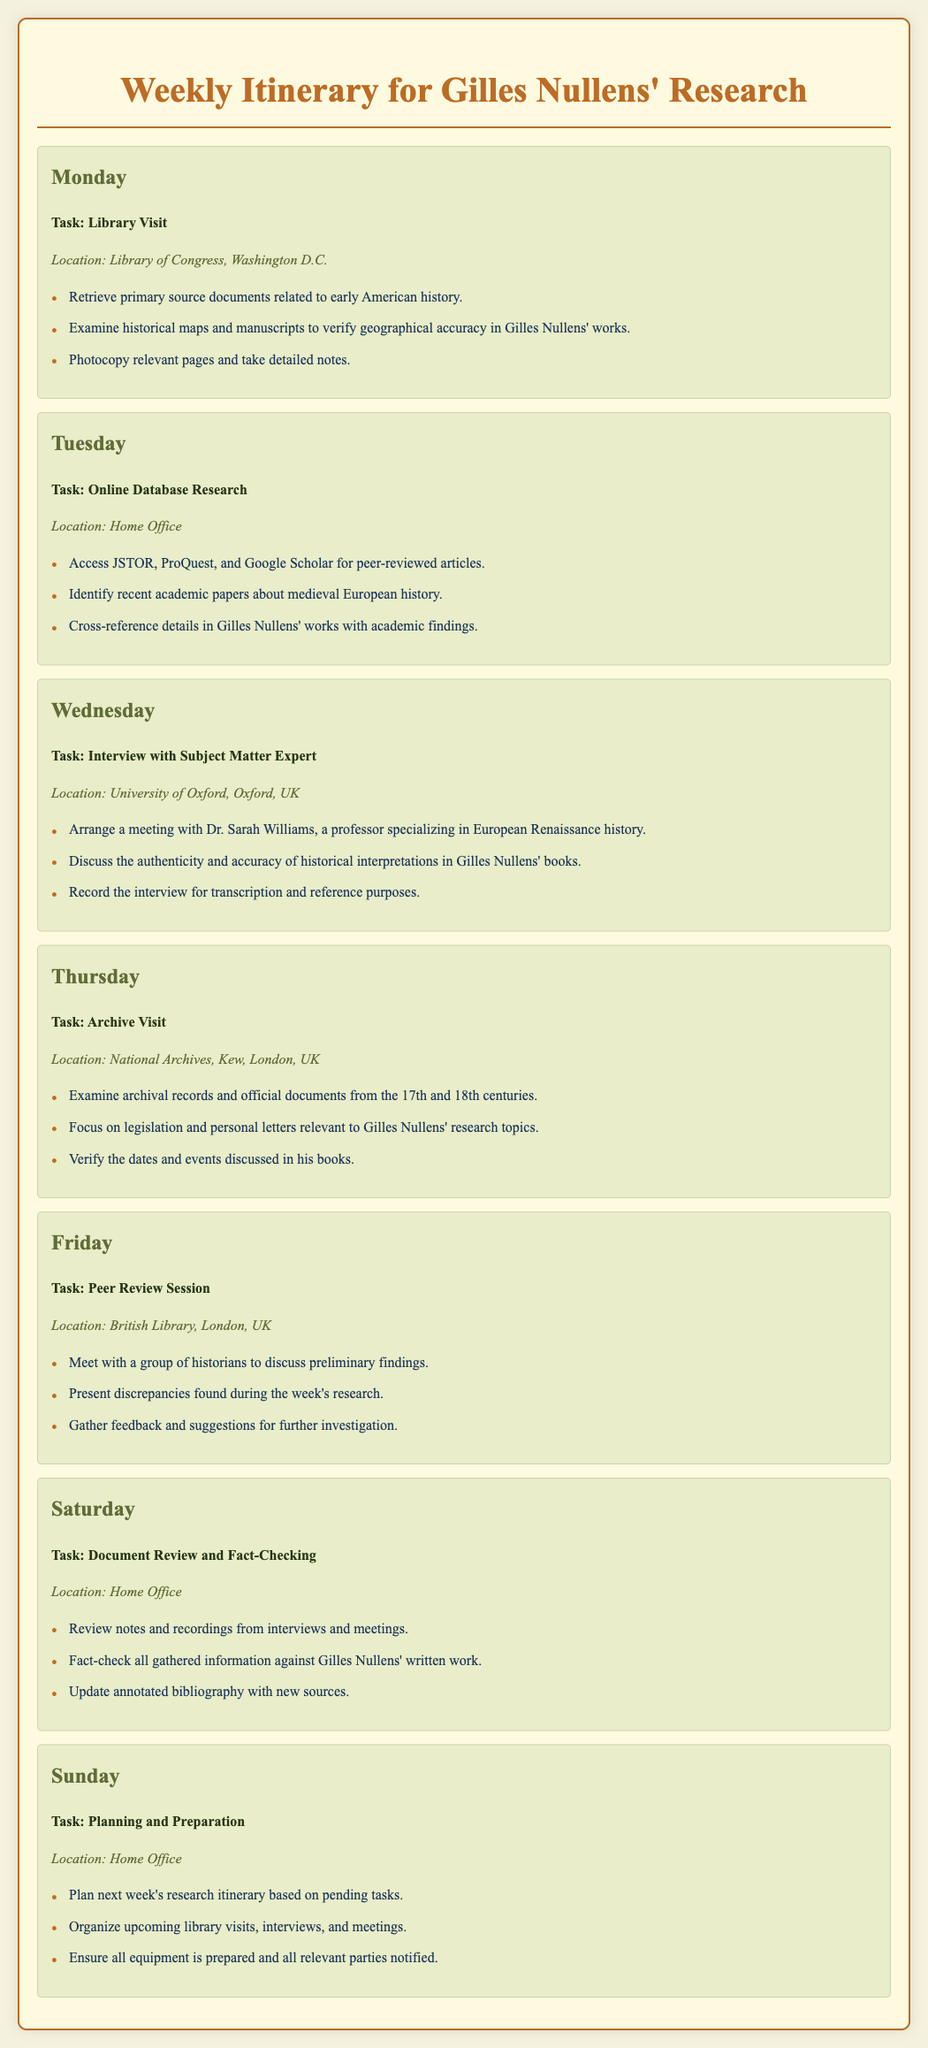What is the task for Monday? The task for Monday involves a library visit to retrieve primary source documents and examine historical maps.
Answer: Library Visit Where is the location for the interview on Wednesday? The document states that the interview with the subject matter expert is taking place at the University of Oxford, Oxford, UK.
Answer: University of Oxford, Oxford, UK Who is the subject matter expert being interviewed? The document provides the name of the expert to be interviewed, who is Dr. Sarah Williams.
Answer: Dr. Sarah Williams What is one task planned for Saturday? The document lists several tasks for Saturday, one of which is to review notes and recordings from interviews and meetings.
Answer: Review notes and recordings What type of session is scheduled for Friday? The itinerary specifies that a peer review session is to be held on Friday.
Answer: Peer Review Session What is a specific activity on Tuesday? On Tuesday, accessing online database research for peer-reviewed articles is mentioned as an activity.
Answer: Access JSTOR, ProQuest, and Google Scholar What is the primary focus of the archive visit on Thursday? The primary focus mentioned for Thursday's archive visit is to examine archival records and official documents from the 17th and 18th centuries.
Answer: Examine archival records How many days are planned for research tasks in this itinerary? The itinerary details tasks for each day of the week, which totals seven days planned for research.
Answer: Seven days What is the location for document review on Saturday? The location specified for document review on Saturday is the home office.
Answer: Home Office 